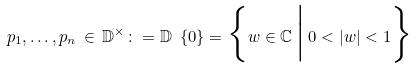Convert formula to latex. <formula><loc_0><loc_0><loc_500><loc_500>p _ { 1 } , \dots , p _ { n } \, \in \, \mathbb { D } ^ { \times } \colon = \mathbb { D } \ \{ 0 \} = \Big \{ w \in \mathbb { C } \, \Big | \, 0 < | w | < 1 \Big \}</formula> 